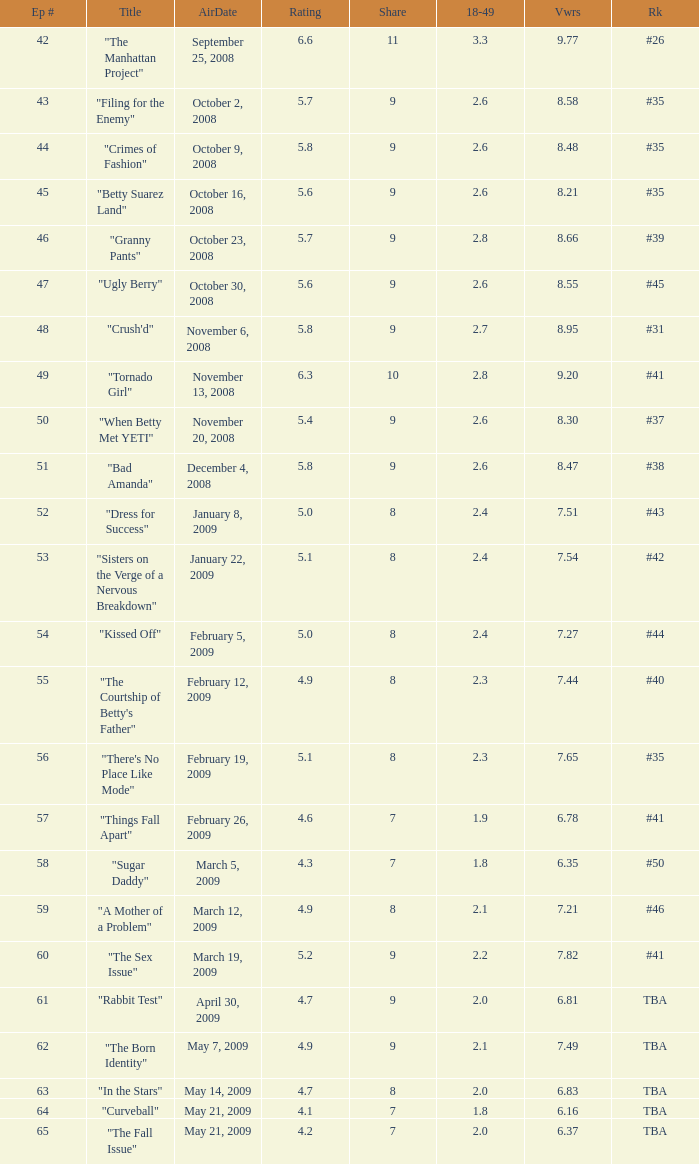What is the Air Date that has a 18–49 larger than 1.9, less than 7.54 viewers and a rating less than 4.9? April 30, 2009, May 14, 2009, May 21, 2009. 